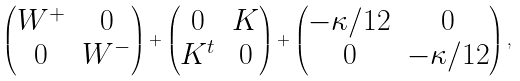<formula> <loc_0><loc_0><loc_500><loc_500>\begin{pmatrix} W ^ { + } & 0 \\ 0 & W ^ { - } \end{pmatrix} + \begin{pmatrix} 0 & K \\ K ^ { t } & 0 \end{pmatrix} + \begin{pmatrix} - \kappa / 1 2 & 0 \\ 0 & - \kappa / 1 2 \end{pmatrix} ,</formula> 